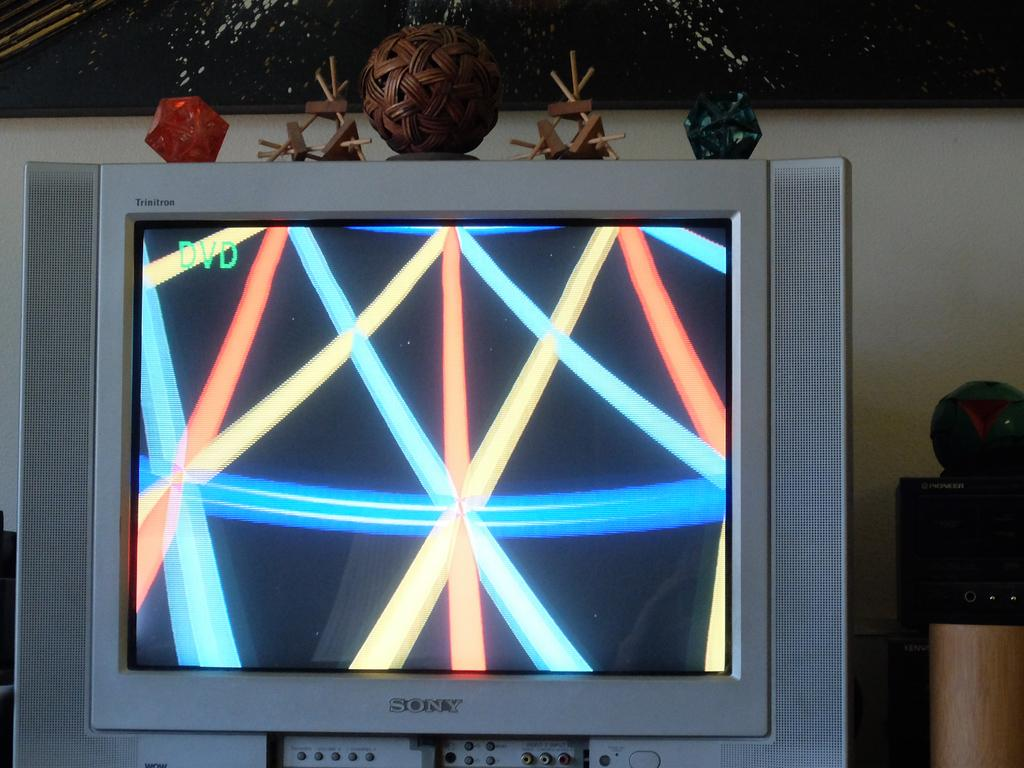<image>
Present a compact description of the photo's key features. A Sony TV with a DVD screen showing. 